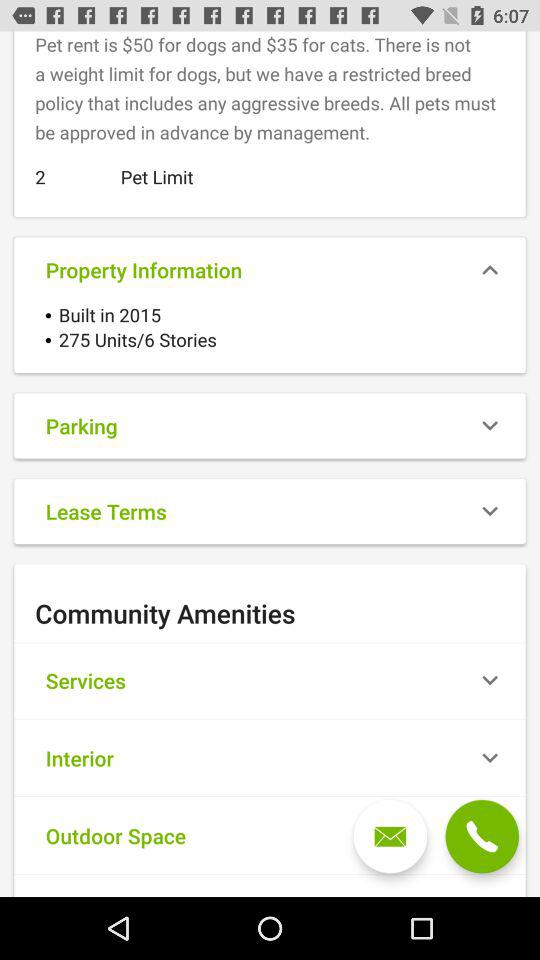How many pets are allowed? There are 2 pets allowed. 